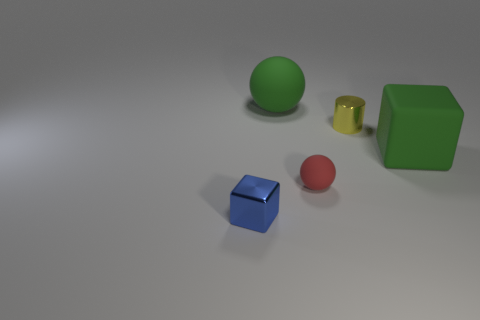Add 4 tiny gray rubber things. How many objects exist? 9 Subtract all balls. How many objects are left? 3 Add 4 small gray blocks. How many small gray blocks exist? 4 Subtract 1 yellow cylinders. How many objects are left? 4 Subtract all cyan matte things. Subtract all tiny blue blocks. How many objects are left? 4 Add 1 yellow metal cylinders. How many yellow metal cylinders are left? 2 